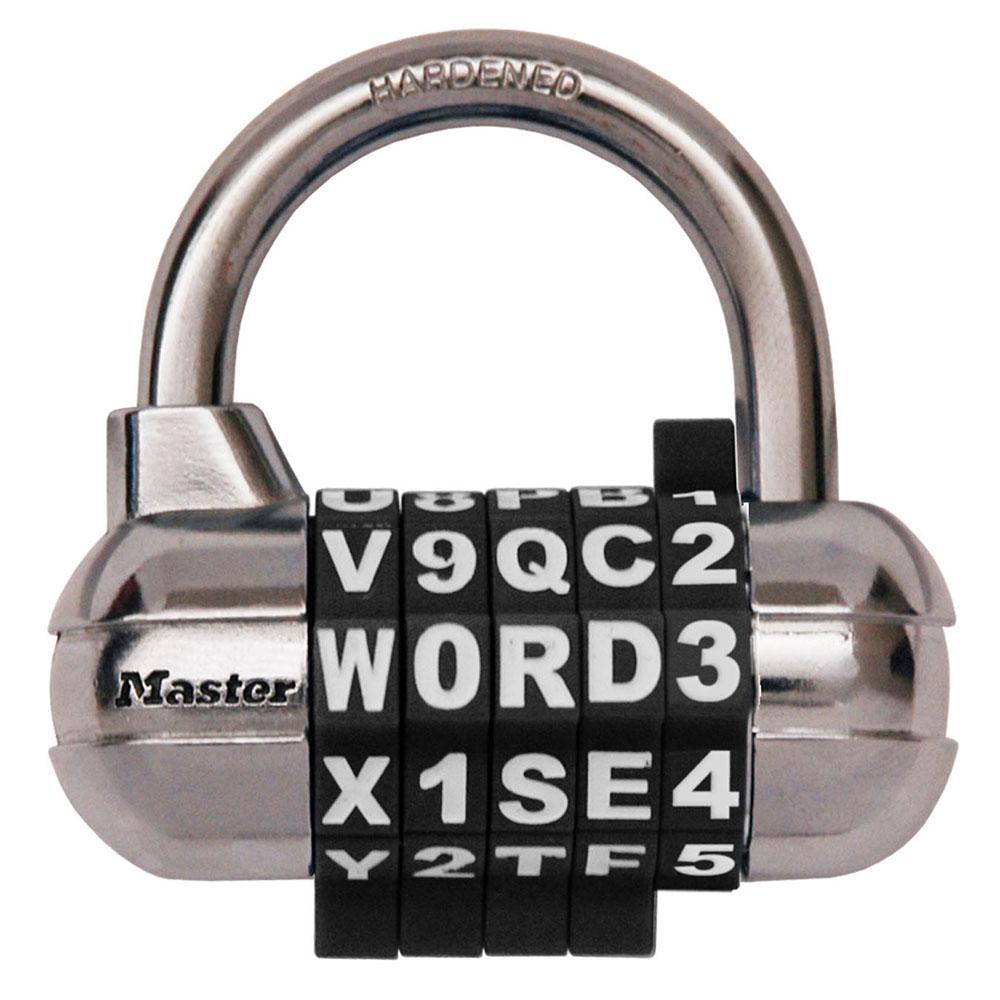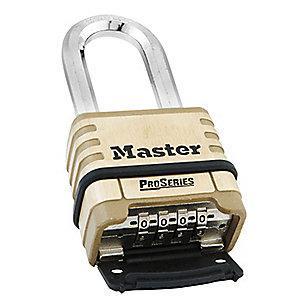The first image is the image on the left, the second image is the image on the right. For the images displayed, is the sentence "A lock in one image is round with a front dial and optional key, while a second image shows at least one padlock with number belts that scroll." factually correct? Answer yes or no. No. The first image is the image on the left, the second image is the image on the right. For the images shown, is this caption "An image shows a round lock with a key next to it, but not inserted in it." true? Answer yes or no. No. 